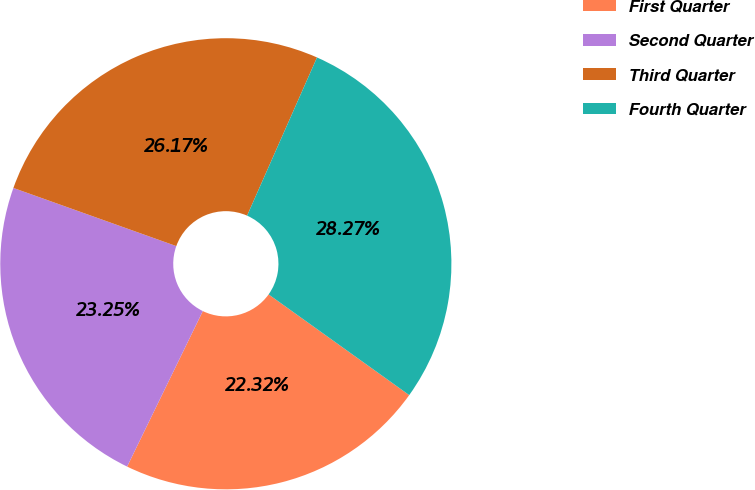Convert chart. <chart><loc_0><loc_0><loc_500><loc_500><pie_chart><fcel>First Quarter<fcel>Second Quarter<fcel>Third Quarter<fcel>Fourth Quarter<nl><fcel>22.32%<fcel>23.25%<fcel>26.17%<fcel>28.27%<nl></chart> 